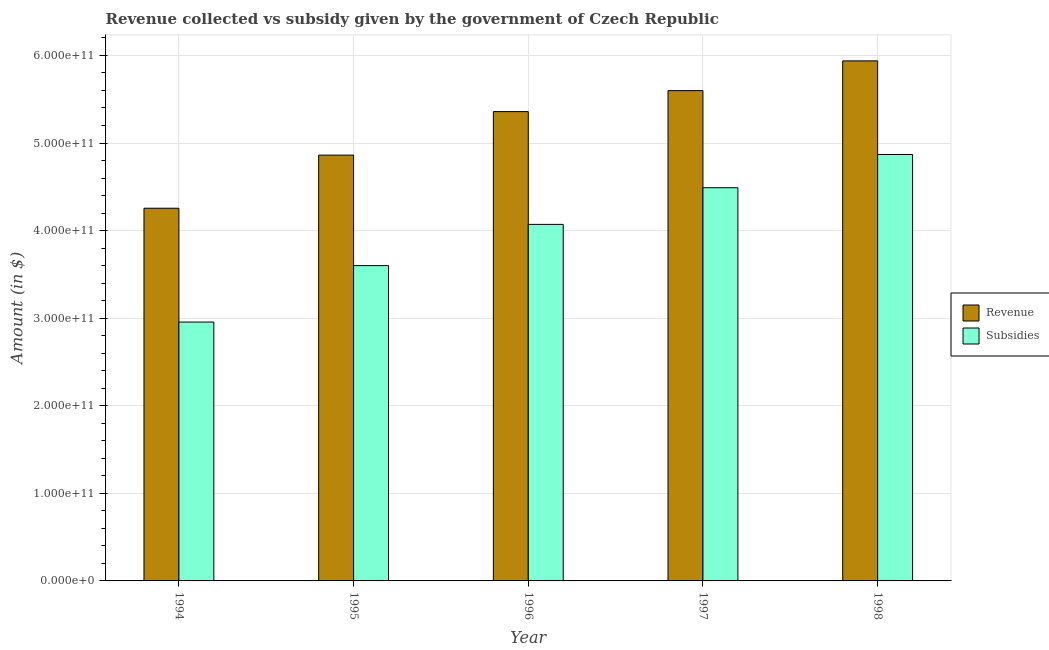How many different coloured bars are there?
Ensure brevity in your answer.  2. Are the number of bars per tick equal to the number of legend labels?
Offer a very short reply. Yes. Are the number of bars on each tick of the X-axis equal?
Keep it short and to the point. Yes. What is the amount of subsidies given in 1995?
Provide a succinct answer. 3.60e+11. Across all years, what is the maximum amount of revenue collected?
Provide a succinct answer. 5.94e+11. Across all years, what is the minimum amount of revenue collected?
Offer a very short reply. 4.26e+11. What is the total amount of subsidies given in the graph?
Keep it short and to the point. 2.00e+12. What is the difference between the amount of subsidies given in 1995 and that in 1997?
Your response must be concise. -8.89e+1. What is the difference between the amount of revenue collected in 1995 and the amount of subsidies given in 1997?
Your answer should be compact. -7.36e+1. What is the average amount of subsidies given per year?
Keep it short and to the point. 4.00e+11. What is the ratio of the amount of subsidies given in 1994 to that in 1995?
Give a very brief answer. 0.82. Is the amount of subsidies given in 1994 less than that in 1995?
Your answer should be very brief. Yes. Is the difference between the amount of subsidies given in 1994 and 1998 greater than the difference between the amount of revenue collected in 1994 and 1998?
Provide a short and direct response. No. What is the difference between the highest and the second highest amount of revenue collected?
Keep it short and to the point. 3.40e+1. What is the difference between the highest and the lowest amount of revenue collected?
Give a very brief answer. 1.68e+11. Is the sum of the amount of revenue collected in 1995 and 1997 greater than the maximum amount of subsidies given across all years?
Keep it short and to the point. Yes. What does the 2nd bar from the left in 1996 represents?
Your response must be concise. Subsidies. What does the 1st bar from the right in 1994 represents?
Offer a terse response. Subsidies. How many bars are there?
Offer a terse response. 10. Are all the bars in the graph horizontal?
Keep it short and to the point. No. What is the difference between two consecutive major ticks on the Y-axis?
Offer a terse response. 1.00e+11. Does the graph contain any zero values?
Ensure brevity in your answer.  No. Does the graph contain grids?
Give a very brief answer. Yes. Where does the legend appear in the graph?
Make the answer very short. Center right. How many legend labels are there?
Provide a succinct answer. 2. What is the title of the graph?
Offer a terse response. Revenue collected vs subsidy given by the government of Czech Republic. What is the label or title of the Y-axis?
Provide a succinct answer. Amount (in $). What is the Amount (in $) in Revenue in 1994?
Your answer should be very brief. 4.26e+11. What is the Amount (in $) of Subsidies in 1994?
Your answer should be very brief. 2.96e+11. What is the Amount (in $) of Revenue in 1995?
Provide a short and direct response. 4.86e+11. What is the Amount (in $) of Subsidies in 1995?
Offer a very short reply. 3.60e+11. What is the Amount (in $) in Revenue in 1996?
Provide a short and direct response. 5.36e+11. What is the Amount (in $) of Subsidies in 1996?
Your answer should be very brief. 4.07e+11. What is the Amount (in $) in Revenue in 1997?
Provide a succinct answer. 5.60e+11. What is the Amount (in $) in Subsidies in 1997?
Make the answer very short. 4.49e+11. What is the Amount (in $) of Revenue in 1998?
Offer a terse response. 5.94e+11. What is the Amount (in $) in Subsidies in 1998?
Make the answer very short. 4.87e+11. Across all years, what is the maximum Amount (in $) in Revenue?
Offer a terse response. 5.94e+11. Across all years, what is the maximum Amount (in $) in Subsidies?
Your answer should be compact. 4.87e+11. Across all years, what is the minimum Amount (in $) in Revenue?
Keep it short and to the point. 4.26e+11. Across all years, what is the minimum Amount (in $) in Subsidies?
Your answer should be compact. 2.96e+11. What is the total Amount (in $) in Revenue in the graph?
Your answer should be compact. 2.60e+12. What is the total Amount (in $) in Subsidies in the graph?
Ensure brevity in your answer.  2.00e+12. What is the difference between the Amount (in $) in Revenue in 1994 and that in 1995?
Provide a succinct answer. -6.07e+1. What is the difference between the Amount (in $) of Subsidies in 1994 and that in 1995?
Your answer should be compact. -6.44e+1. What is the difference between the Amount (in $) of Revenue in 1994 and that in 1996?
Provide a short and direct response. -1.10e+11. What is the difference between the Amount (in $) of Subsidies in 1994 and that in 1996?
Your response must be concise. -1.12e+11. What is the difference between the Amount (in $) of Revenue in 1994 and that in 1997?
Provide a succinct answer. -1.34e+11. What is the difference between the Amount (in $) in Subsidies in 1994 and that in 1997?
Provide a succinct answer. -1.53e+11. What is the difference between the Amount (in $) in Revenue in 1994 and that in 1998?
Provide a short and direct response. -1.68e+11. What is the difference between the Amount (in $) in Subsidies in 1994 and that in 1998?
Offer a terse response. -1.91e+11. What is the difference between the Amount (in $) in Revenue in 1995 and that in 1996?
Offer a very short reply. -4.97e+1. What is the difference between the Amount (in $) of Subsidies in 1995 and that in 1996?
Your response must be concise. -4.71e+1. What is the difference between the Amount (in $) of Revenue in 1995 and that in 1997?
Your answer should be very brief. -7.36e+1. What is the difference between the Amount (in $) in Subsidies in 1995 and that in 1997?
Ensure brevity in your answer.  -8.89e+1. What is the difference between the Amount (in $) of Revenue in 1995 and that in 1998?
Make the answer very short. -1.08e+11. What is the difference between the Amount (in $) in Subsidies in 1995 and that in 1998?
Give a very brief answer. -1.27e+11. What is the difference between the Amount (in $) in Revenue in 1996 and that in 1997?
Offer a very short reply. -2.39e+1. What is the difference between the Amount (in $) in Subsidies in 1996 and that in 1997?
Make the answer very short. -4.19e+1. What is the difference between the Amount (in $) in Revenue in 1996 and that in 1998?
Ensure brevity in your answer.  -5.79e+1. What is the difference between the Amount (in $) of Subsidies in 1996 and that in 1998?
Provide a short and direct response. -7.98e+1. What is the difference between the Amount (in $) of Revenue in 1997 and that in 1998?
Offer a very short reply. -3.40e+1. What is the difference between the Amount (in $) of Subsidies in 1997 and that in 1998?
Your answer should be compact. -3.80e+1. What is the difference between the Amount (in $) of Revenue in 1994 and the Amount (in $) of Subsidies in 1995?
Offer a terse response. 6.55e+1. What is the difference between the Amount (in $) in Revenue in 1994 and the Amount (in $) in Subsidies in 1996?
Keep it short and to the point. 1.84e+1. What is the difference between the Amount (in $) in Revenue in 1994 and the Amount (in $) in Subsidies in 1997?
Give a very brief answer. -2.34e+1. What is the difference between the Amount (in $) of Revenue in 1994 and the Amount (in $) of Subsidies in 1998?
Keep it short and to the point. -6.14e+1. What is the difference between the Amount (in $) of Revenue in 1995 and the Amount (in $) of Subsidies in 1996?
Make the answer very short. 7.91e+1. What is the difference between the Amount (in $) in Revenue in 1995 and the Amount (in $) in Subsidies in 1997?
Provide a succinct answer. 3.72e+1. What is the difference between the Amount (in $) of Revenue in 1995 and the Amount (in $) of Subsidies in 1998?
Offer a very short reply. -7.24e+08. What is the difference between the Amount (in $) in Revenue in 1996 and the Amount (in $) in Subsidies in 1997?
Offer a terse response. 8.69e+1. What is the difference between the Amount (in $) of Revenue in 1996 and the Amount (in $) of Subsidies in 1998?
Your answer should be compact. 4.90e+1. What is the difference between the Amount (in $) of Revenue in 1997 and the Amount (in $) of Subsidies in 1998?
Your answer should be very brief. 7.29e+1. What is the average Amount (in $) of Revenue per year?
Provide a short and direct response. 5.20e+11. What is the average Amount (in $) in Subsidies per year?
Give a very brief answer. 4.00e+11. In the year 1994, what is the difference between the Amount (in $) in Revenue and Amount (in $) in Subsidies?
Make the answer very short. 1.30e+11. In the year 1995, what is the difference between the Amount (in $) of Revenue and Amount (in $) of Subsidies?
Provide a succinct answer. 1.26e+11. In the year 1996, what is the difference between the Amount (in $) of Revenue and Amount (in $) of Subsidies?
Your answer should be very brief. 1.29e+11. In the year 1997, what is the difference between the Amount (in $) of Revenue and Amount (in $) of Subsidies?
Give a very brief answer. 1.11e+11. In the year 1998, what is the difference between the Amount (in $) in Revenue and Amount (in $) in Subsidies?
Make the answer very short. 1.07e+11. What is the ratio of the Amount (in $) in Revenue in 1994 to that in 1995?
Provide a succinct answer. 0.88. What is the ratio of the Amount (in $) in Subsidies in 1994 to that in 1995?
Your answer should be compact. 0.82. What is the ratio of the Amount (in $) of Revenue in 1994 to that in 1996?
Your answer should be very brief. 0.79. What is the ratio of the Amount (in $) of Subsidies in 1994 to that in 1996?
Your response must be concise. 0.73. What is the ratio of the Amount (in $) of Revenue in 1994 to that in 1997?
Make the answer very short. 0.76. What is the ratio of the Amount (in $) of Subsidies in 1994 to that in 1997?
Provide a short and direct response. 0.66. What is the ratio of the Amount (in $) in Revenue in 1994 to that in 1998?
Your answer should be very brief. 0.72. What is the ratio of the Amount (in $) in Subsidies in 1994 to that in 1998?
Provide a succinct answer. 0.61. What is the ratio of the Amount (in $) in Revenue in 1995 to that in 1996?
Give a very brief answer. 0.91. What is the ratio of the Amount (in $) in Subsidies in 1995 to that in 1996?
Offer a very short reply. 0.88. What is the ratio of the Amount (in $) in Revenue in 1995 to that in 1997?
Keep it short and to the point. 0.87. What is the ratio of the Amount (in $) of Subsidies in 1995 to that in 1997?
Ensure brevity in your answer.  0.8. What is the ratio of the Amount (in $) in Revenue in 1995 to that in 1998?
Ensure brevity in your answer.  0.82. What is the ratio of the Amount (in $) in Subsidies in 1995 to that in 1998?
Your answer should be very brief. 0.74. What is the ratio of the Amount (in $) of Revenue in 1996 to that in 1997?
Keep it short and to the point. 0.96. What is the ratio of the Amount (in $) in Subsidies in 1996 to that in 1997?
Your answer should be compact. 0.91. What is the ratio of the Amount (in $) of Revenue in 1996 to that in 1998?
Your response must be concise. 0.9. What is the ratio of the Amount (in $) in Subsidies in 1996 to that in 1998?
Make the answer very short. 0.84. What is the ratio of the Amount (in $) of Revenue in 1997 to that in 1998?
Offer a very short reply. 0.94. What is the ratio of the Amount (in $) of Subsidies in 1997 to that in 1998?
Keep it short and to the point. 0.92. What is the difference between the highest and the second highest Amount (in $) in Revenue?
Ensure brevity in your answer.  3.40e+1. What is the difference between the highest and the second highest Amount (in $) in Subsidies?
Make the answer very short. 3.80e+1. What is the difference between the highest and the lowest Amount (in $) in Revenue?
Keep it short and to the point. 1.68e+11. What is the difference between the highest and the lowest Amount (in $) in Subsidies?
Your answer should be compact. 1.91e+11. 